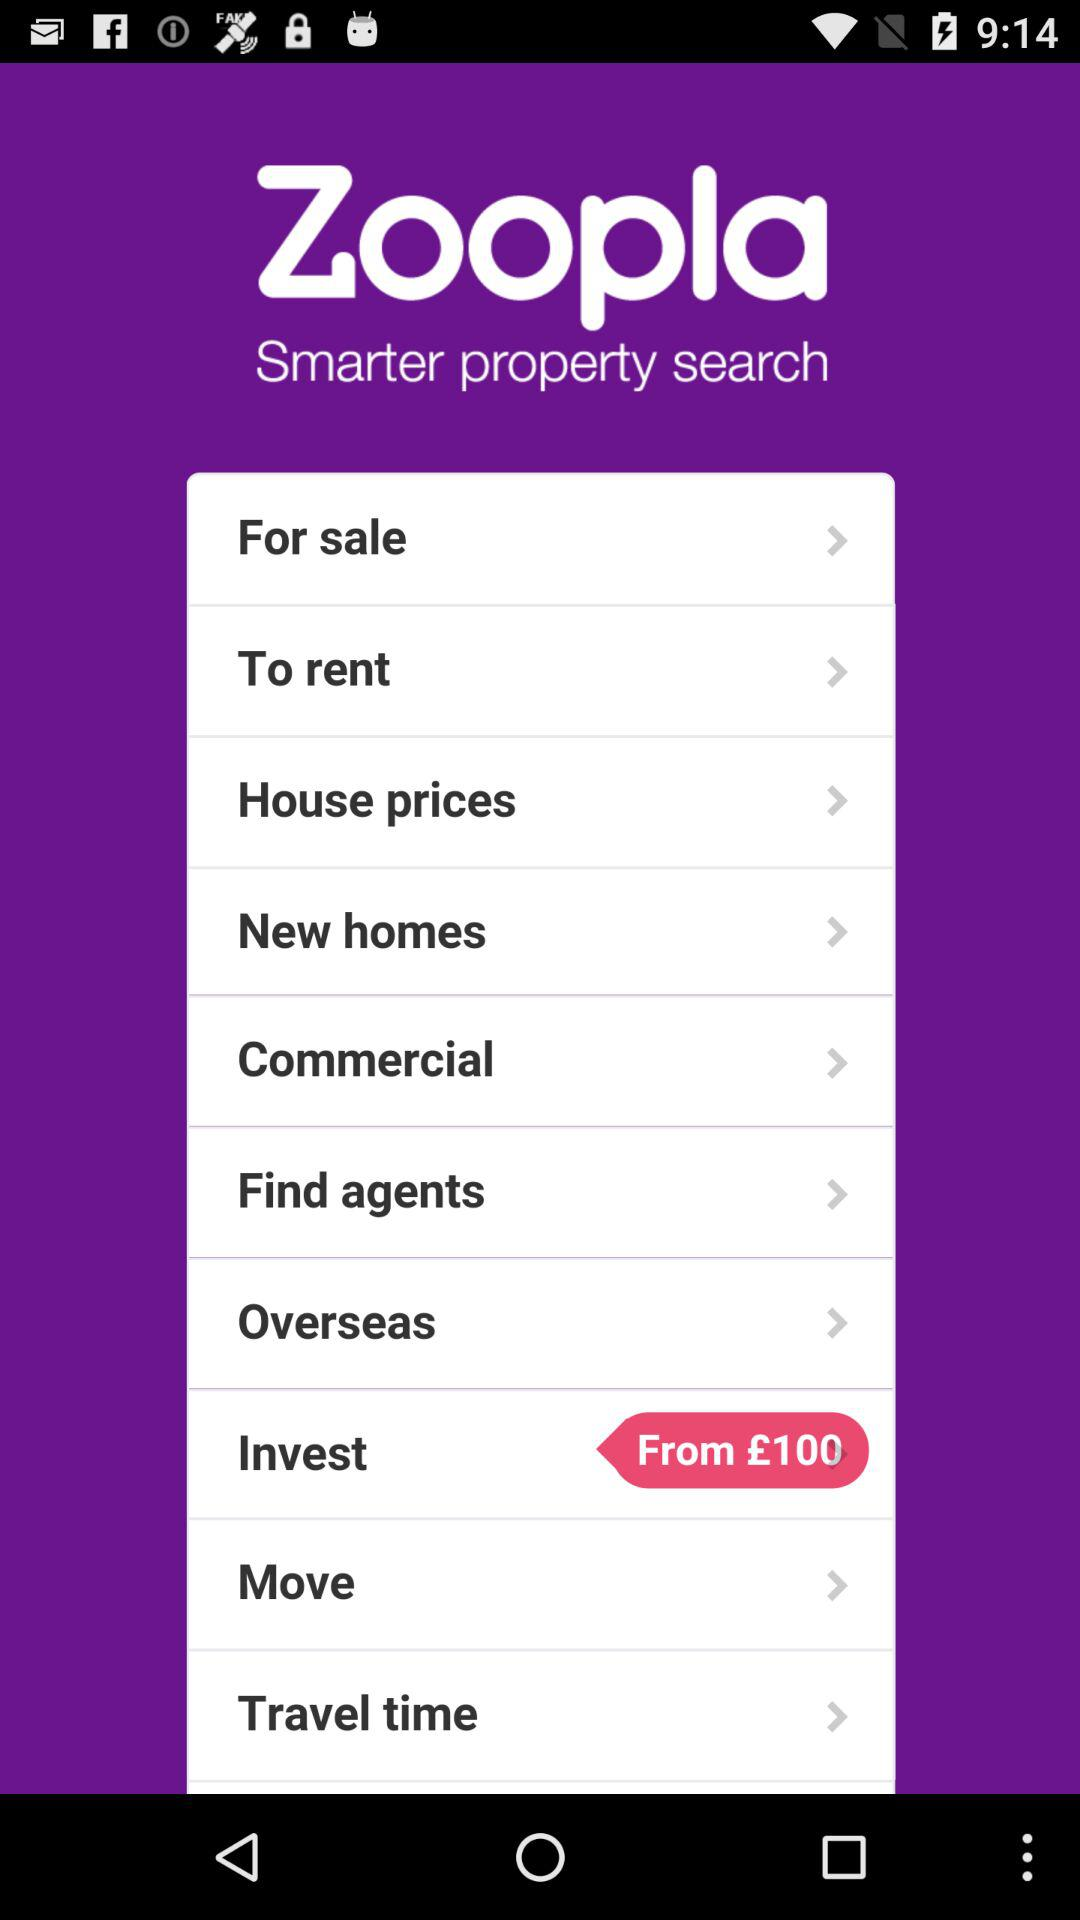What is the application name? The application name is "Zoopla". 